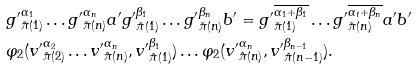Convert formula to latex. <formula><loc_0><loc_0><loc_500><loc_500>& { g ^ { \prime } } _ { \tilde { \pi } ( 1 ) } ^ { \alpha _ { 1 } } \dots { g ^ { \prime } } _ { \tilde { \pi } ( n ) } ^ { \alpha _ { n } } { a ^ { \prime } } { g ^ { \prime } } _ { \tilde { \pi } ( 1 ) } ^ { \beta _ { 1 } } \dots { g ^ { \prime } } _ { \tilde { \pi } ( n ) } ^ { \beta _ { n } } { b ^ { \prime } } = { g ^ { \prime } } _ { \tilde { \pi } ( 1 ) } ^ { \overline { \alpha _ { 1 } + \beta _ { 1 } } } \dots { g ^ { \prime } } _ { \tilde { \pi } ( n ) } ^ { \overline { \alpha _ { t } + \beta _ { n } } } { a ^ { \prime } } { b ^ { \prime } } \\ & \varphi _ { 2 } ( { v ^ { \prime } } _ { \hat { \pi } ( 2 ) } ^ { \alpha _ { 2 } } \dots { v ^ { \prime } } _ { \hat { \pi } ( n ) } ^ { \alpha _ { n } } , { v ^ { \prime } } _ { \hat { \pi } ( 1 ) } ^ { \beta _ { 1 } } ) \dots \varphi _ { 2 } ( { v ^ { \prime } } _ { \hat { \pi } ( n ) } ^ { \alpha _ { n } } , { v ^ { \prime } } _ { \hat { \pi } ( n - 1 ) } ^ { \beta _ { n - 1 } } ) .</formula> 